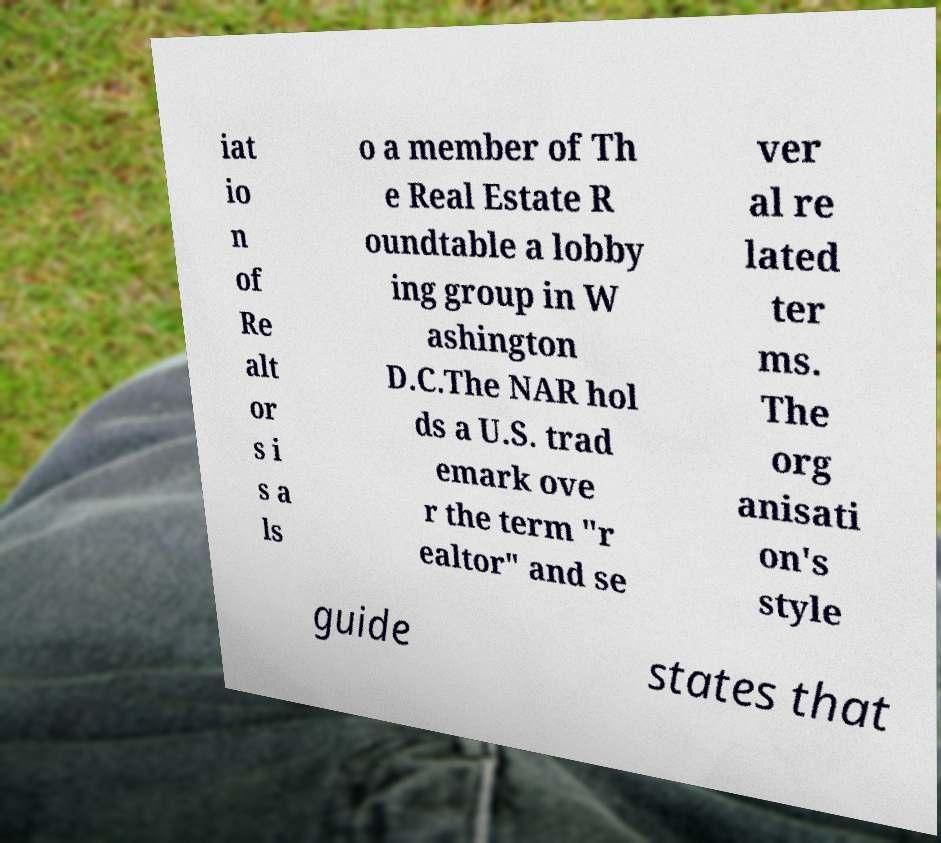Can you accurately transcribe the text from the provided image for me? iat io n of Re alt or s i s a ls o a member of Th e Real Estate R oundtable a lobby ing group in W ashington D.C.The NAR hol ds a U.S. trad emark ove r the term "r ealtor" and se ver al re lated ter ms. The org anisati on's style guide states that 